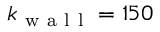Convert formula to latex. <formula><loc_0><loc_0><loc_500><loc_500>k _ { w a l l } = 1 5 0</formula> 